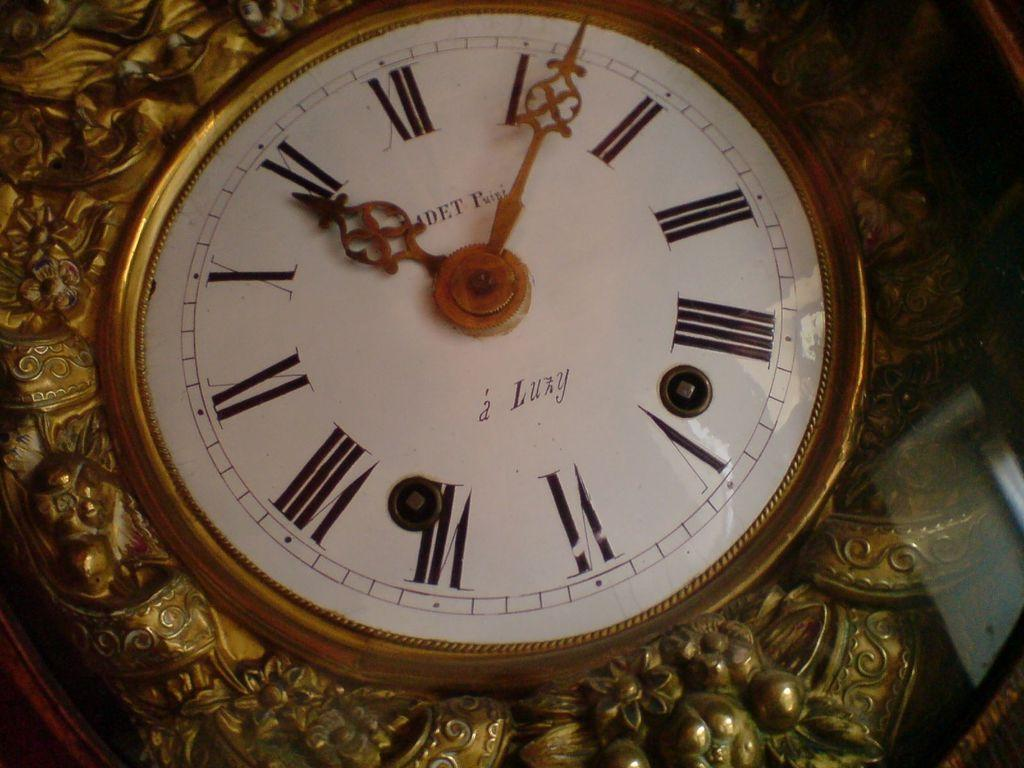Provide a one-sentence caption for the provided image. An ornate a Luzy clock with a time of 10:07. 